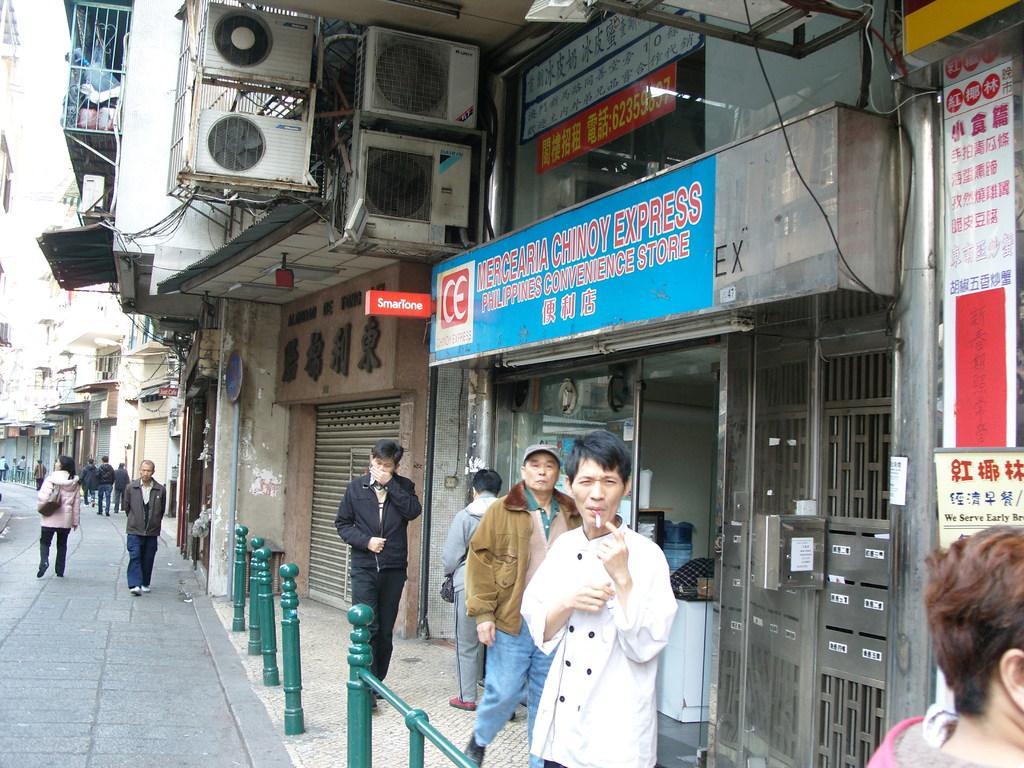In one or two sentences, can you explain what this image depicts? In this image we can see a group of people standing on the ground. In the foreground we can see some poles. In the background, we can see sign boards with some text, a group of buildings with windows, gates, railing, some air conditioners and the sky. 